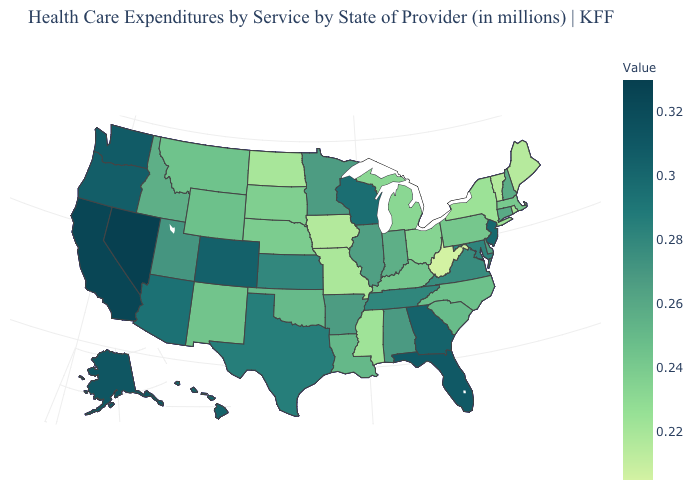Among the states that border Maine , which have the lowest value?
Write a very short answer. New Hampshire. Which states have the lowest value in the USA?
Short answer required. West Virginia. Does West Virginia have the lowest value in the USA?
Be succinct. Yes. Which states hav the highest value in the West?
Write a very short answer. Nevada. Which states hav the highest value in the West?
Quick response, please. Nevada. Does New Hampshire have the lowest value in the Northeast?
Answer briefly. No. 